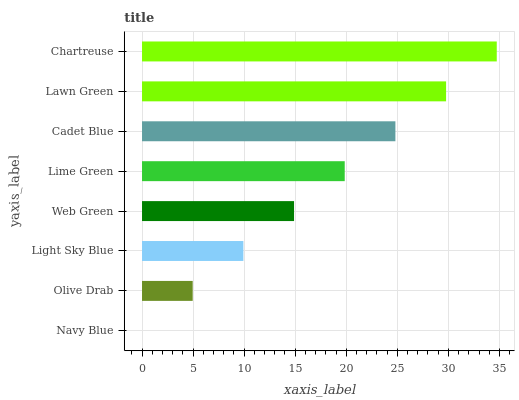Is Navy Blue the minimum?
Answer yes or no. Yes. Is Chartreuse the maximum?
Answer yes or no. Yes. Is Olive Drab the minimum?
Answer yes or no. No. Is Olive Drab the maximum?
Answer yes or no. No. Is Olive Drab greater than Navy Blue?
Answer yes or no. Yes. Is Navy Blue less than Olive Drab?
Answer yes or no. Yes. Is Navy Blue greater than Olive Drab?
Answer yes or no. No. Is Olive Drab less than Navy Blue?
Answer yes or no. No. Is Lime Green the high median?
Answer yes or no. Yes. Is Web Green the low median?
Answer yes or no. Yes. Is Lawn Green the high median?
Answer yes or no. No. Is Chartreuse the low median?
Answer yes or no. No. 